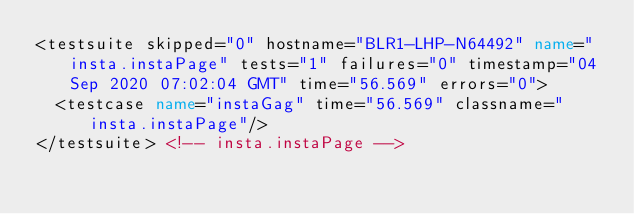<code> <loc_0><loc_0><loc_500><loc_500><_XML_><testsuite skipped="0" hostname="BLR1-LHP-N64492" name="insta.instaPage" tests="1" failures="0" timestamp="04 Sep 2020 07:02:04 GMT" time="56.569" errors="0">
  <testcase name="instaGag" time="56.569" classname="insta.instaPage"/>
</testsuite> <!-- insta.instaPage -->
</code> 